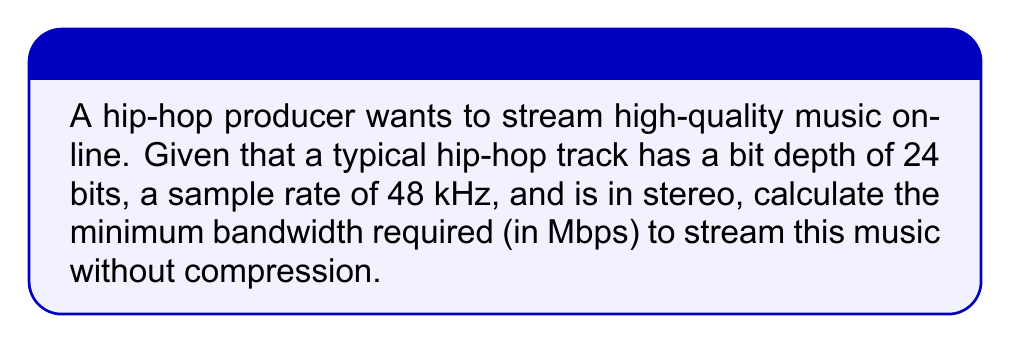Help me with this question. To calculate the bandwidth required for streaming uncompressed audio, we need to use the formula:

$$ \text{Bandwidth} = \text{Bit Depth} \times \text{Sample Rate} \times \text{Number of Channels} $$

Let's break it down step-by-step:

1) Bit Depth: 24 bits
2) Sample Rate: 48 kHz = 48,000 Hz
3) Number of Channels: 2 (stereo)

Now, let's plug these values into our formula:

$$ \text{Bandwidth} = 24 \text{ bits} \times 48,000 \text{ Hz} \times 2 $$

$$ = 2,304,000 \text{ bits per second} $$

To convert this to Megabits per second (Mbps), we divide by 1,000,000:

$$ \frac{2,304,000}{1,000,000} = 2.304 \text{ Mbps} $$

Therefore, the minimum bandwidth required to stream this high-quality hip-hop music without compression is 2.304 Mbps.
Answer: 2.304 Mbps 